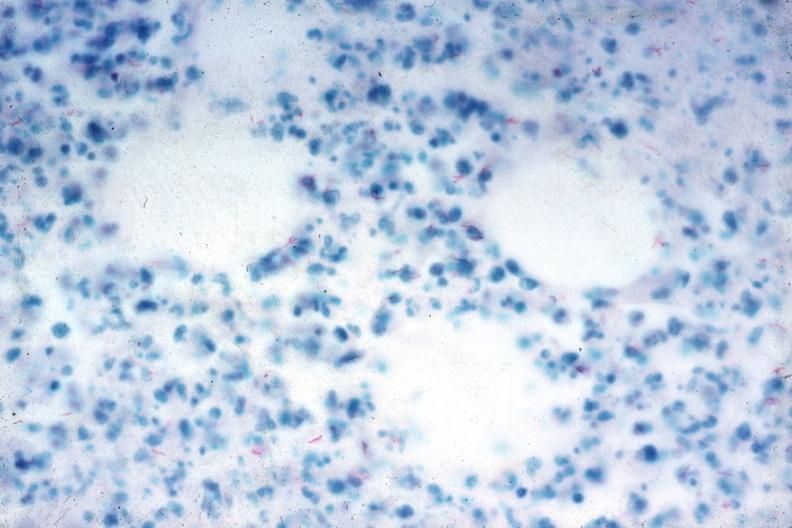what stain numerous acid fast bacilli very good slide?
Answer the question using a single word or phrase. Acid 